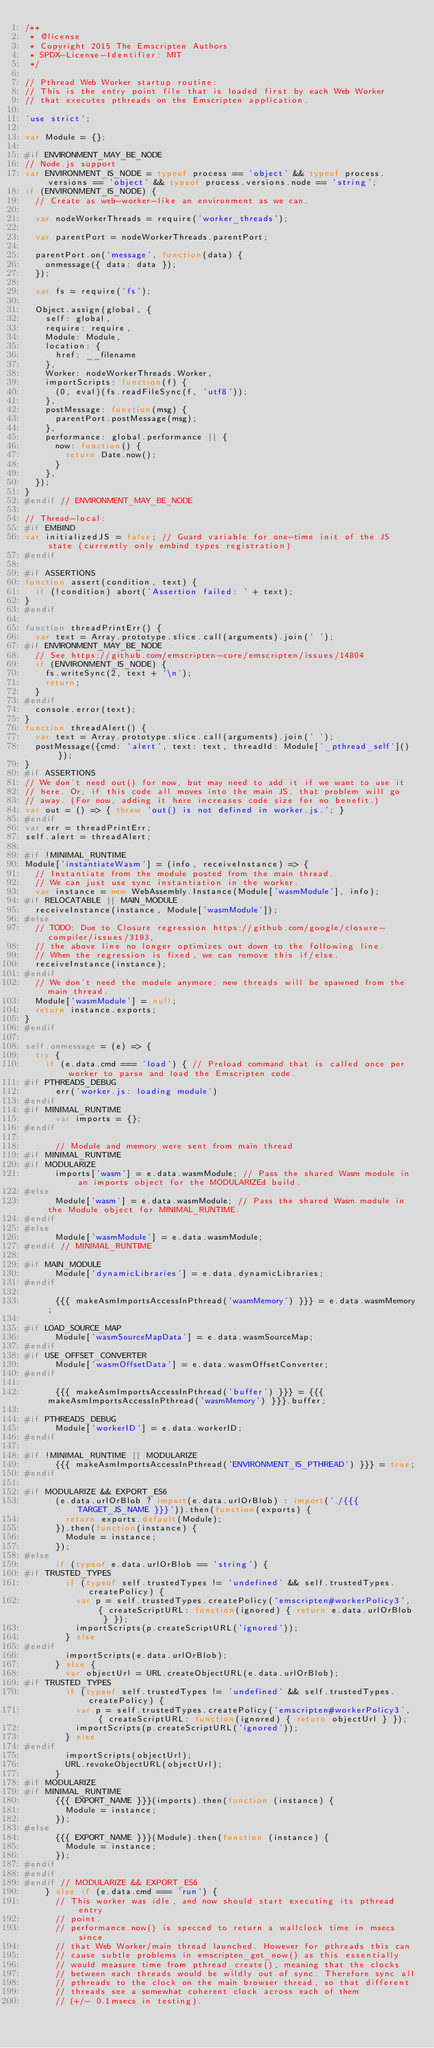<code> <loc_0><loc_0><loc_500><loc_500><_JavaScript_>/**
 * @license
 * Copyright 2015 The Emscripten Authors
 * SPDX-License-Identifier: MIT
 */

// Pthread Web Worker startup routine:
// This is the entry point file that is loaded first by each Web Worker
// that executes pthreads on the Emscripten application.

'use strict';

var Module = {};

#if ENVIRONMENT_MAY_BE_NODE
// Node.js support
var ENVIRONMENT_IS_NODE = typeof process == 'object' && typeof process.versions == 'object' && typeof process.versions.node == 'string';
if (ENVIRONMENT_IS_NODE) {
  // Create as web-worker-like an environment as we can.

  var nodeWorkerThreads = require('worker_threads');

  var parentPort = nodeWorkerThreads.parentPort;

  parentPort.on('message', function(data) {
    onmessage({ data: data });
  });

  var fs = require('fs');

  Object.assign(global, {
    self: global,
    require: require,
    Module: Module,
    location: {
      href: __filename
    },
    Worker: nodeWorkerThreads.Worker,
    importScripts: function(f) {
      (0, eval)(fs.readFileSync(f, 'utf8'));
    },
    postMessage: function(msg) {
      parentPort.postMessage(msg);
    },
    performance: global.performance || {
      now: function() {
        return Date.now();
      }
    },
  });
}
#endif // ENVIRONMENT_MAY_BE_NODE

// Thread-local:
#if EMBIND
var initializedJS = false; // Guard variable for one-time init of the JS state (currently only embind types registration)
#endif

#if ASSERTIONS
function assert(condition, text) {
  if (!condition) abort('Assertion failed: ' + text);
}
#endif

function threadPrintErr() {
  var text = Array.prototype.slice.call(arguments).join(' ');
#if ENVIRONMENT_MAY_BE_NODE
  // See https://github.com/emscripten-core/emscripten/issues/14804
  if (ENVIRONMENT_IS_NODE) {
    fs.writeSync(2, text + '\n');
    return;
  }
#endif
  console.error(text);
}
function threadAlert() {
  var text = Array.prototype.slice.call(arguments).join(' ');
  postMessage({cmd: 'alert', text: text, threadId: Module['_pthread_self']()});
}
#if ASSERTIONS
// We don't need out() for now, but may need to add it if we want to use it
// here. Or, if this code all moves into the main JS, that problem will go
// away. (For now, adding it here increases code size for no benefit.)
var out = () => { throw 'out() is not defined in worker.js.'; }
#endif
var err = threadPrintErr;
self.alert = threadAlert;

#if !MINIMAL_RUNTIME
Module['instantiateWasm'] = (info, receiveInstance) => {
  // Instantiate from the module posted from the main thread.
  // We can just use sync instantiation in the worker.
  var instance = new WebAssembly.Instance(Module['wasmModule'], info);
#if RELOCATABLE || MAIN_MODULE
  receiveInstance(instance, Module['wasmModule']);
#else
  // TODO: Due to Closure regression https://github.com/google/closure-compiler/issues/3193,
  // the above line no longer optimizes out down to the following line.
  // When the regression is fixed, we can remove this if/else.
  receiveInstance(instance);
#endif
  // We don't need the module anymore; new threads will be spawned from the main thread.
  Module['wasmModule'] = null;
  return instance.exports;
}
#endif

self.onmessage = (e) => {
  try {
    if (e.data.cmd === 'load') { // Preload command that is called once per worker to parse and load the Emscripten code.
#if PTHREADS_DEBUG
      err('worker.js: loading module')
#endif
#if MINIMAL_RUNTIME
      var imports = {};
#endif

      // Module and memory were sent from main thread
#if MINIMAL_RUNTIME
#if MODULARIZE
      imports['wasm'] = e.data.wasmModule; // Pass the shared Wasm module in an imports object for the MODULARIZEd build.
#else
      Module['wasm'] = e.data.wasmModule; // Pass the shared Wasm module in the Module object for MINIMAL_RUNTIME.
#endif
#else
      Module['wasmModule'] = e.data.wasmModule;
#endif // MINIMAL_RUNTIME

#if MAIN_MODULE
      Module['dynamicLibraries'] = e.data.dynamicLibraries;
#endif

      {{{ makeAsmImportsAccessInPthread('wasmMemory') }}} = e.data.wasmMemory;

#if LOAD_SOURCE_MAP
      Module['wasmSourceMapData'] = e.data.wasmSourceMap;
#endif
#if USE_OFFSET_CONVERTER
      Module['wasmOffsetData'] = e.data.wasmOffsetConverter;
#endif

      {{{ makeAsmImportsAccessInPthread('buffer') }}} = {{{ makeAsmImportsAccessInPthread('wasmMemory') }}}.buffer;

#if PTHREADS_DEBUG
      Module['workerID'] = e.data.workerID;
#endif

#if !MINIMAL_RUNTIME || MODULARIZE
      {{{ makeAsmImportsAccessInPthread('ENVIRONMENT_IS_PTHREAD') }}} = true;
#endif

#if MODULARIZE && EXPORT_ES6
      (e.data.urlOrBlob ? import(e.data.urlOrBlob) : import('./{{{ TARGET_JS_NAME }}}')).then(function(exports) {
        return exports.default(Module);
      }).then(function(instance) {
        Module = instance;
      });
#else
      if (typeof e.data.urlOrBlob == 'string') {
#if TRUSTED_TYPES
        if (typeof self.trustedTypes != 'undefined' && self.trustedTypes.createPolicy) {
          var p = self.trustedTypes.createPolicy('emscripten#workerPolicy3', { createScriptURL: function(ignored) { return e.data.urlOrBlob } });
          importScripts(p.createScriptURL('ignored'));
        } else
#endif
        importScripts(e.data.urlOrBlob);
      } else {
        var objectUrl = URL.createObjectURL(e.data.urlOrBlob);
#if TRUSTED_TYPES
        if (typeof self.trustedTypes != 'undefined' && self.trustedTypes.createPolicy) {
          var p = self.trustedTypes.createPolicy('emscripten#workerPolicy3', { createScriptURL: function(ignored) { return objectUrl } });
          importScripts(p.createScriptURL('ignored'));
        } else
#endif
        importScripts(objectUrl);
        URL.revokeObjectURL(objectUrl);
      }
#if MODULARIZE
#if MINIMAL_RUNTIME
      {{{ EXPORT_NAME }}}(imports).then(function (instance) {
        Module = instance;
      });
#else
      {{{ EXPORT_NAME }}}(Module).then(function (instance) {
        Module = instance;
      });
#endif
#endif
#endif // MODULARIZE && EXPORT_ES6
    } else if (e.data.cmd === 'run') {
      // This worker was idle, and now should start executing its pthread entry
      // point.
      // performance.now() is specced to return a wallclock time in msecs since
      // that Web Worker/main thread launched. However for pthreads this can
      // cause subtle problems in emscripten_get_now() as this essentially
      // would measure time from pthread_create(), meaning that the clocks
      // between each threads would be wildly out of sync. Therefore sync all
      // pthreads to the clock on the main browser thread, so that different
      // threads see a somewhat coherent clock across each of them
      // (+/- 0.1msecs in testing).</code> 